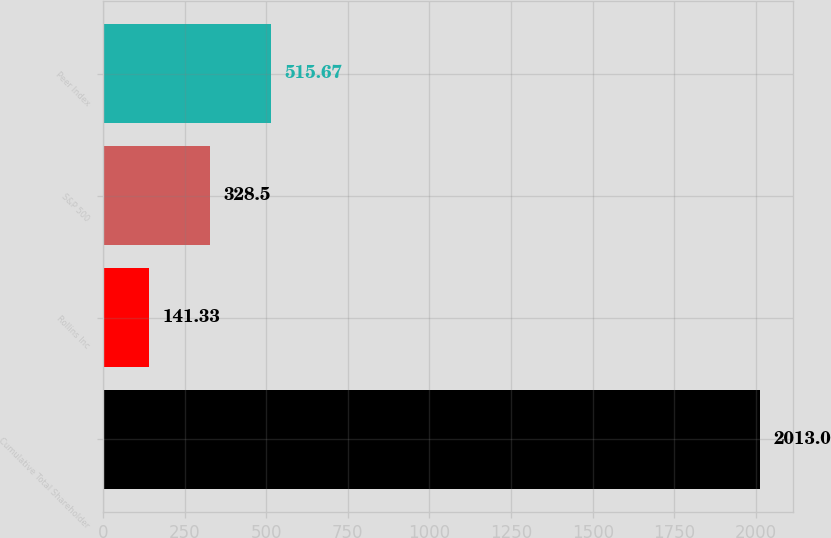Convert chart to OTSL. <chart><loc_0><loc_0><loc_500><loc_500><bar_chart><fcel>Cumulative Total Shareholder<fcel>Rollins Inc<fcel>S&P 500<fcel>Peer Index<nl><fcel>2013<fcel>141.33<fcel>328.5<fcel>515.67<nl></chart> 